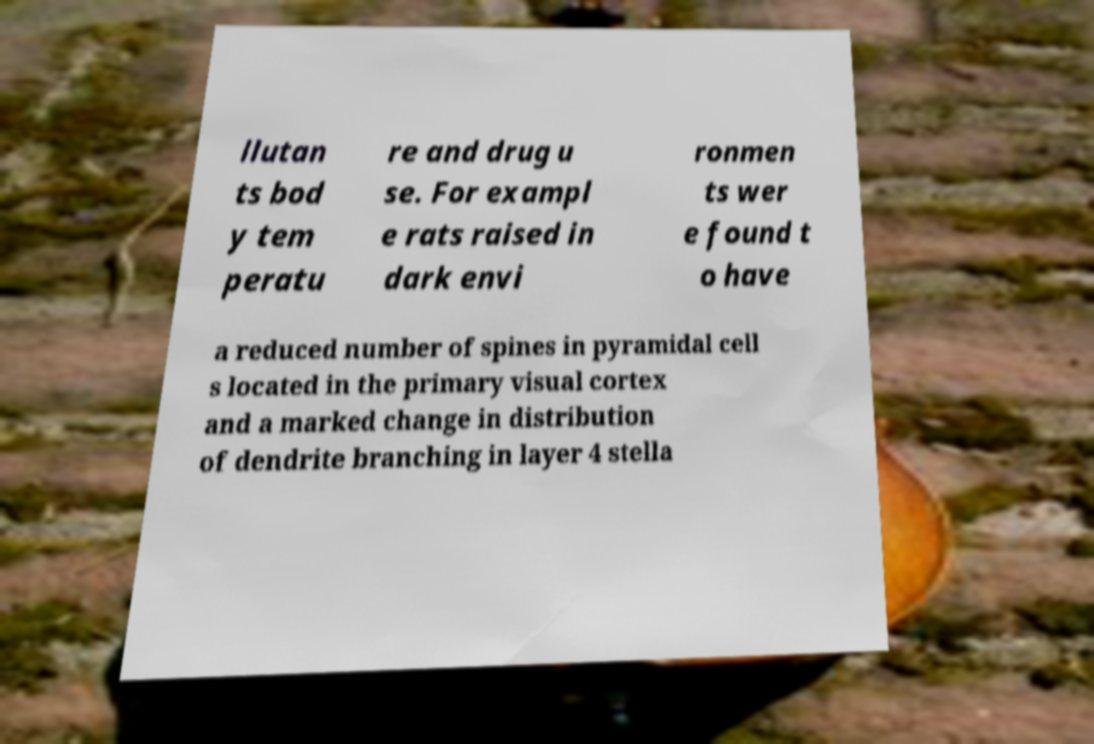Could you extract and type out the text from this image? llutan ts bod y tem peratu re and drug u se. For exampl e rats raised in dark envi ronmen ts wer e found t o have a reduced number of spines in pyramidal cell s located in the primary visual cortex and a marked change in distribution of dendrite branching in layer 4 stella 